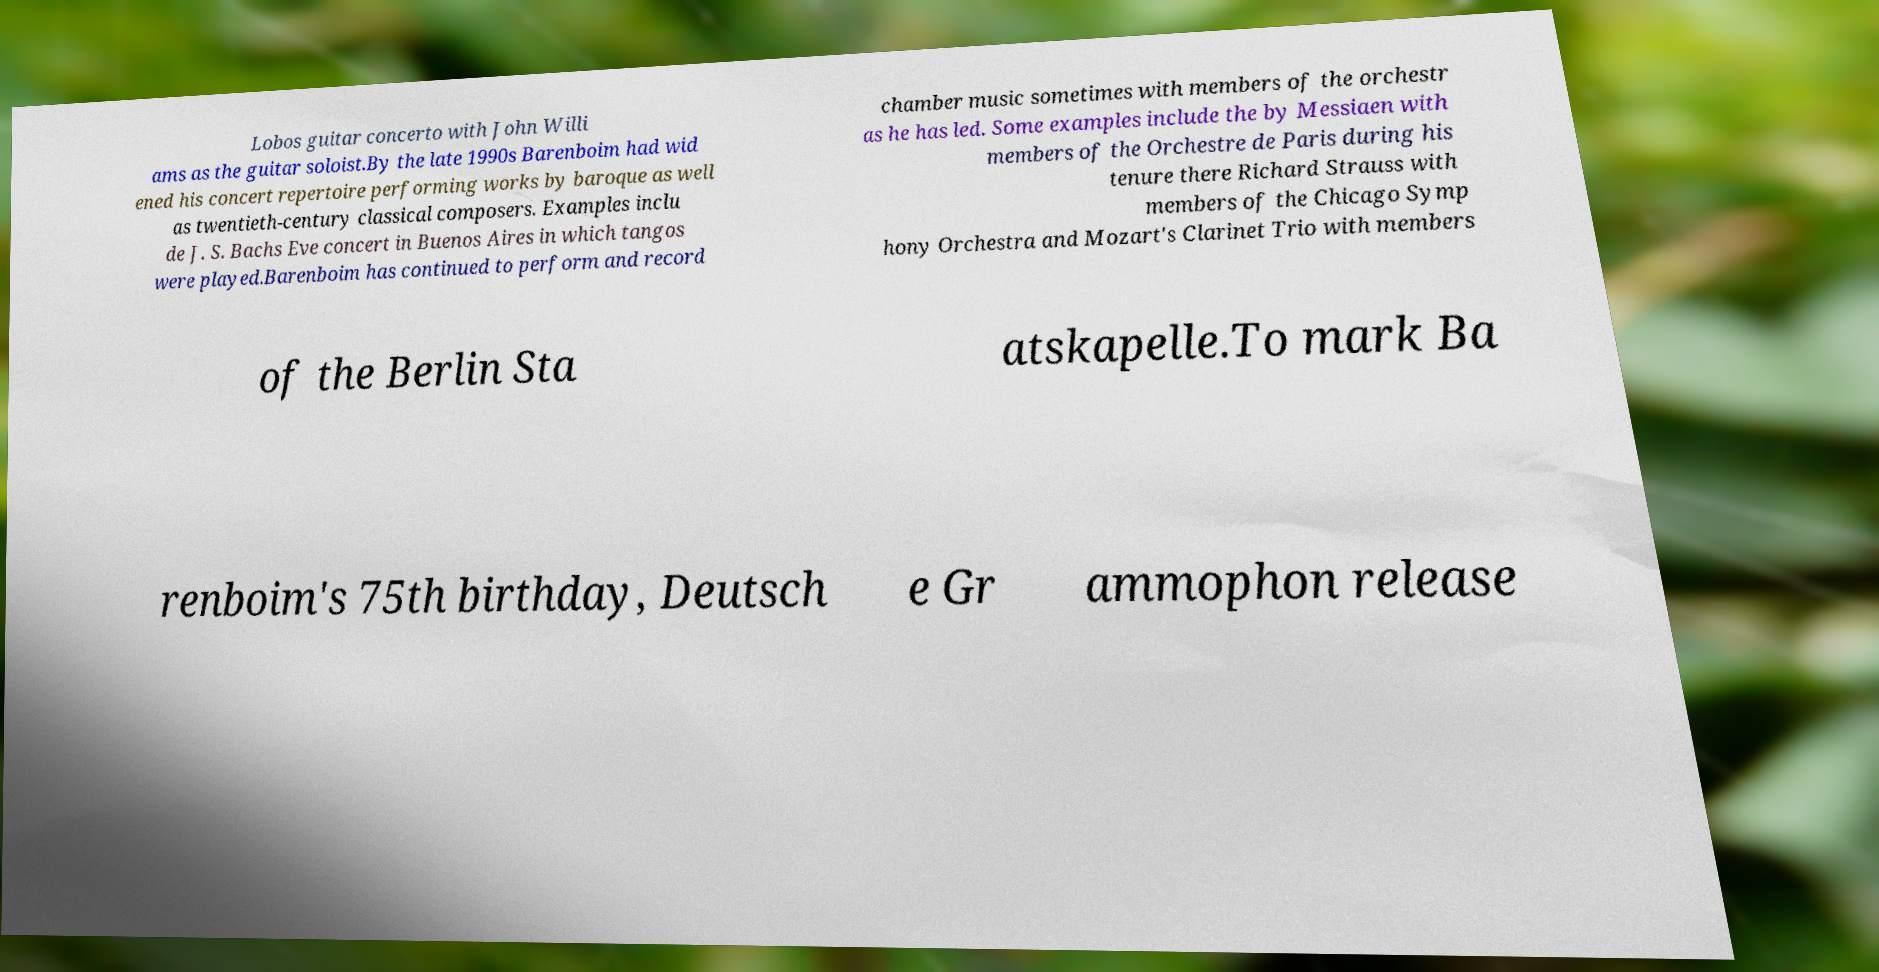What messages or text are displayed in this image? I need them in a readable, typed format. Lobos guitar concerto with John Willi ams as the guitar soloist.By the late 1990s Barenboim had wid ened his concert repertoire performing works by baroque as well as twentieth-century classical composers. Examples inclu de J. S. Bachs Eve concert in Buenos Aires in which tangos were played.Barenboim has continued to perform and record chamber music sometimes with members of the orchestr as he has led. Some examples include the by Messiaen with members of the Orchestre de Paris during his tenure there Richard Strauss with members of the Chicago Symp hony Orchestra and Mozart's Clarinet Trio with members of the Berlin Sta atskapelle.To mark Ba renboim's 75th birthday, Deutsch e Gr ammophon release 